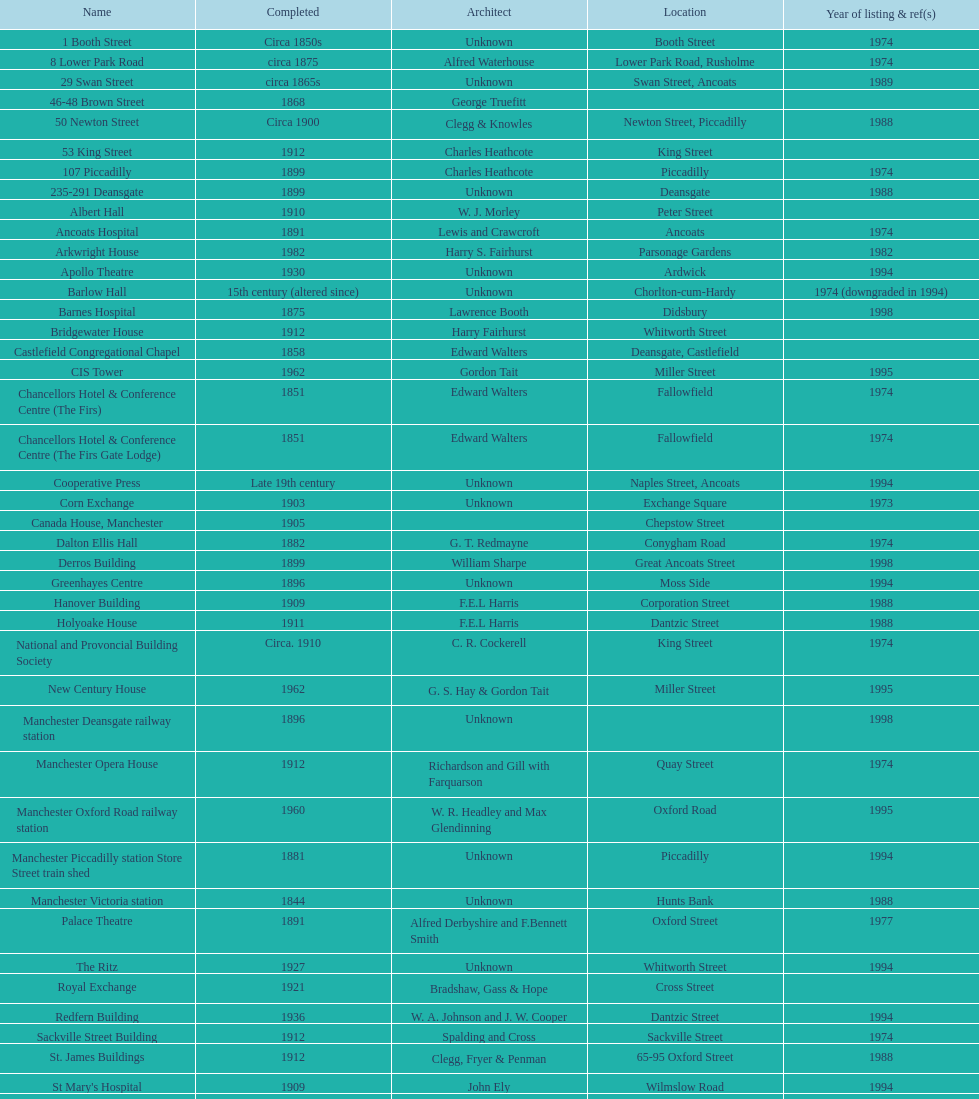Which year witnessed the highest number of listed buildings? 1974. 